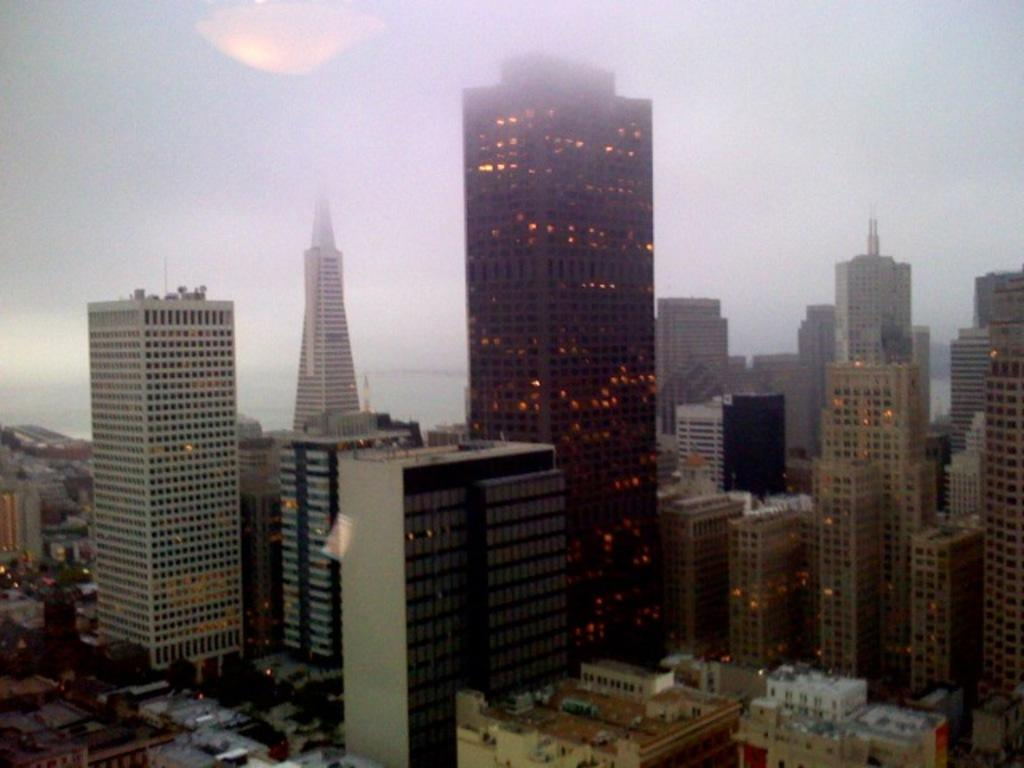What type of structures can be seen in the image? There are buildings in the image. What colors are the buildings? The buildings are in white, cream, and black colors. What else is visible in the image besides the buildings? There are lights and trees visible in the image. What is the color of the sky in the image? The sky is white in color. Can you see a tent in the image? There is no tent present in the image. What type of harmony is being played in the background of the image? There is no music or harmony present in the image; it only contains visual elements. 